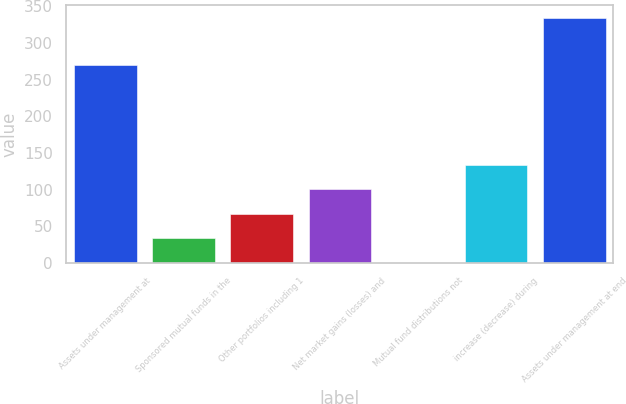Convert chart. <chart><loc_0><loc_0><loc_500><loc_500><bar_chart><fcel>Assets under management at<fcel>Sponsored mutual funds in the<fcel>Other portfolios including 1<fcel>Net market gains (losses) and<fcel>Mutual fund distributions not<fcel>increase (decrease) during<fcel>Assets under management at end<nl><fcel>269.5<fcel>33.92<fcel>67.34<fcel>100.76<fcel>0.5<fcel>134.18<fcel>334.7<nl></chart> 